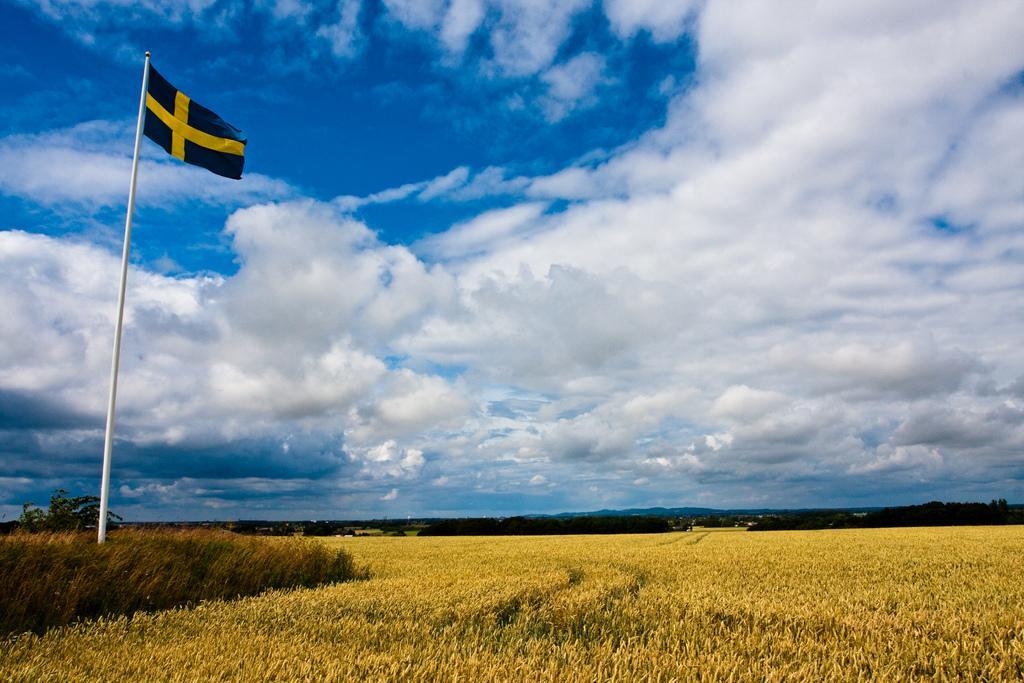In one or two sentences, can you explain what this image depicts? In the picture we can see the surface with full of grass plants and in it we can see a pole with a flag to it and far away we can see some trees, hills and in the background we can see the sky with clouds. 